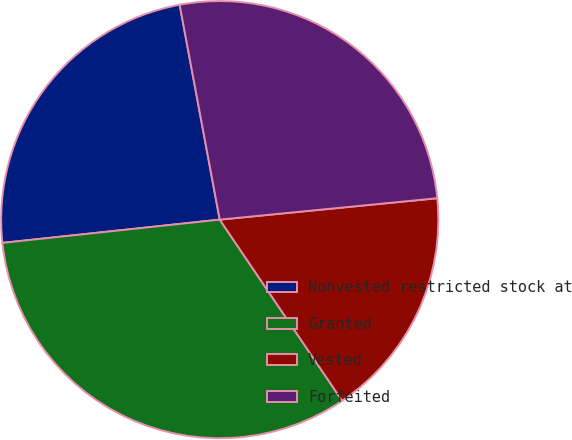Convert chart. <chart><loc_0><loc_0><loc_500><loc_500><pie_chart><fcel>Nonvested restricted stock at<fcel>Granted<fcel>Vested<fcel>Forfeited<nl><fcel>23.76%<fcel>32.76%<fcel>17.1%<fcel>26.37%<nl></chart> 